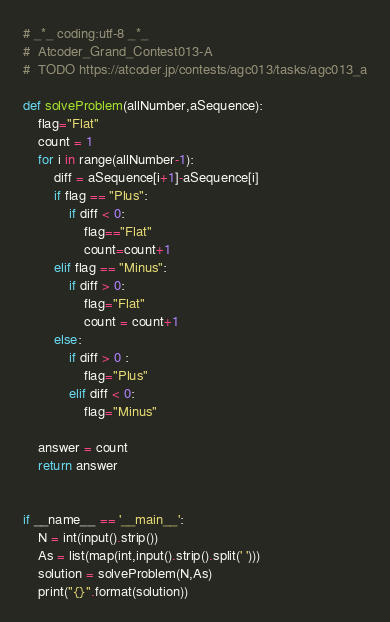Convert code to text. <code><loc_0><loc_0><loc_500><loc_500><_Python_># _*_ coding:utf-8 _*_
#  Atcoder_Grand_Contest013-A
#  TODO https://atcoder.jp/contests/agc013/tasks/agc013_a

def solveProblem(allNumber,aSequence):
	flag="Flat"
	count = 1
	for i in range(allNumber-1):
		diff = aSequence[i+1]-aSequence[i]
		if flag == "Plus":
			if diff < 0:
				flag=="Flat"
				count=count+1
		elif flag == "Minus":
			if diff > 0:
				flag="Flat"
				count = count+1
		else:
			if diff > 0 :
				flag="Plus"
			elif diff < 0:
				flag="Minus"

	answer = count
	return answer


if __name__ == '__main__':
	N = int(input().strip())
	As = list(map(int,input().strip().split(' ')))
	solution = solveProblem(N,As)
	print("{}".format(solution))
</code> 